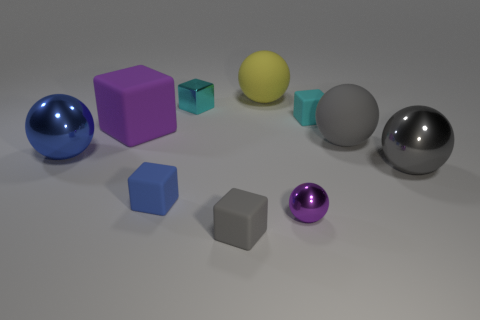The shiny cube has what color?
Provide a short and direct response. Cyan. How many things are tiny blue things or large rubber balls?
Your response must be concise. 3. What material is the yellow object that is the same size as the gray rubber sphere?
Provide a short and direct response. Rubber. There is a cyan block right of the tiny gray object; what size is it?
Offer a very short reply. Small. What material is the blue cube?
Offer a terse response. Rubber. How many objects are balls to the left of the metallic block or small matte objects that are in front of the purple cube?
Your answer should be very brief. 3. How many other things are there of the same color as the shiny cube?
Provide a succinct answer. 1. Do the small cyan metallic object and the tiny cyan object on the right side of the large yellow matte thing have the same shape?
Ensure brevity in your answer.  Yes. Is the number of metal cubes right of the tiny cyan metal object less than the number of blue metal objects that are in front of the tiny purple sphere?
Provide a succinct answer. No. What material is the yellow object that is the same shape as the large blue shiny object?
Provide a short and direct response. Rubber. 